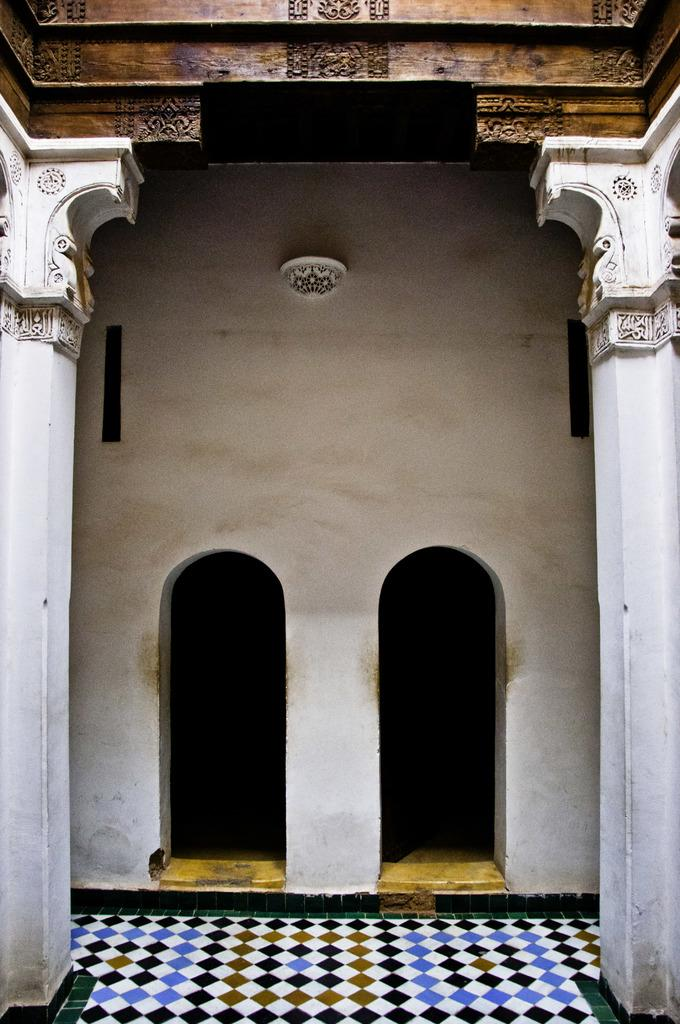What type of structure is present in the image? There is a building in the image. Can you describe the floor visible at the bottom of the image? Yes, there is a floor visible at the bottom of the image. How does the cow cover the request in the image? A: There is no cow or request present in the image; it only features a building and a floor. 